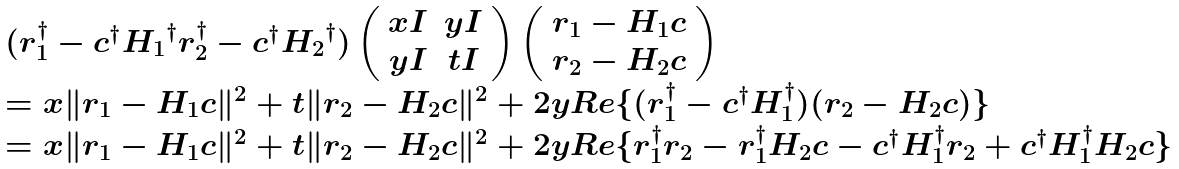<formula> <loc_0><loc_0><loc_500><loc_500>\begin{array} { l } ( { r } _ { 1 } ^ { \dagger } - { c } ^ { \dagger } { H _ { 1 } } ^ { \dagger } { r } _ { 2 } ^ { \dagger } - { c } ^ { \dagger } { H _ { 2 } } ^ { \dagger } ) \left ( \begin{array} { c c } x { I } & y { I } \\ y { I } & t { I } \end{array} \right ) \left ( \begin{array} { c } { r } _ { 1 } - { H } _ { 1 } { c } \\ { r } _ { 2 } - { H } _ { 2 } { c } \end{array} \right ) \\ = x \| { r } _ { 1 } - { H } _ { 1 } { c } \| ^ { 2 } + t \| { r } _ { 2 } - { H } _ { 2 } { c } \| ^ { 2 } + 2 y R e \{ ( { r } _ { 1 } ^ { \dagger } - { c } ^ { \dagger } { H } _ { 1 } ^ { \dagger } ) ( { r } _ { 2 } - { H } _ { 2 } { c } ) \} \\ = x \| { r } _ { 1 } - { H } _ { 1 } { c } \| ^ { 2 } + t \| { r } _ { 2 } - { H } _ { 2 } { c } \| ^ { 2 } + 2 y R e \{ { r } _ { 1 } ^ { \dagger } { r } _ { 2 } - { r } _ { 1 } ^ { \dagger } { H } _ { 2 } { c } - { c } ^ { \dagger } { H } _ { 1 } ^ { \dagger } { r } _ { 2 } + { c } ^ { \dagger } { H } _ { 1 } ^ { \dagger } { H } _ { 2 } { c } \} \end{array}</formula> 